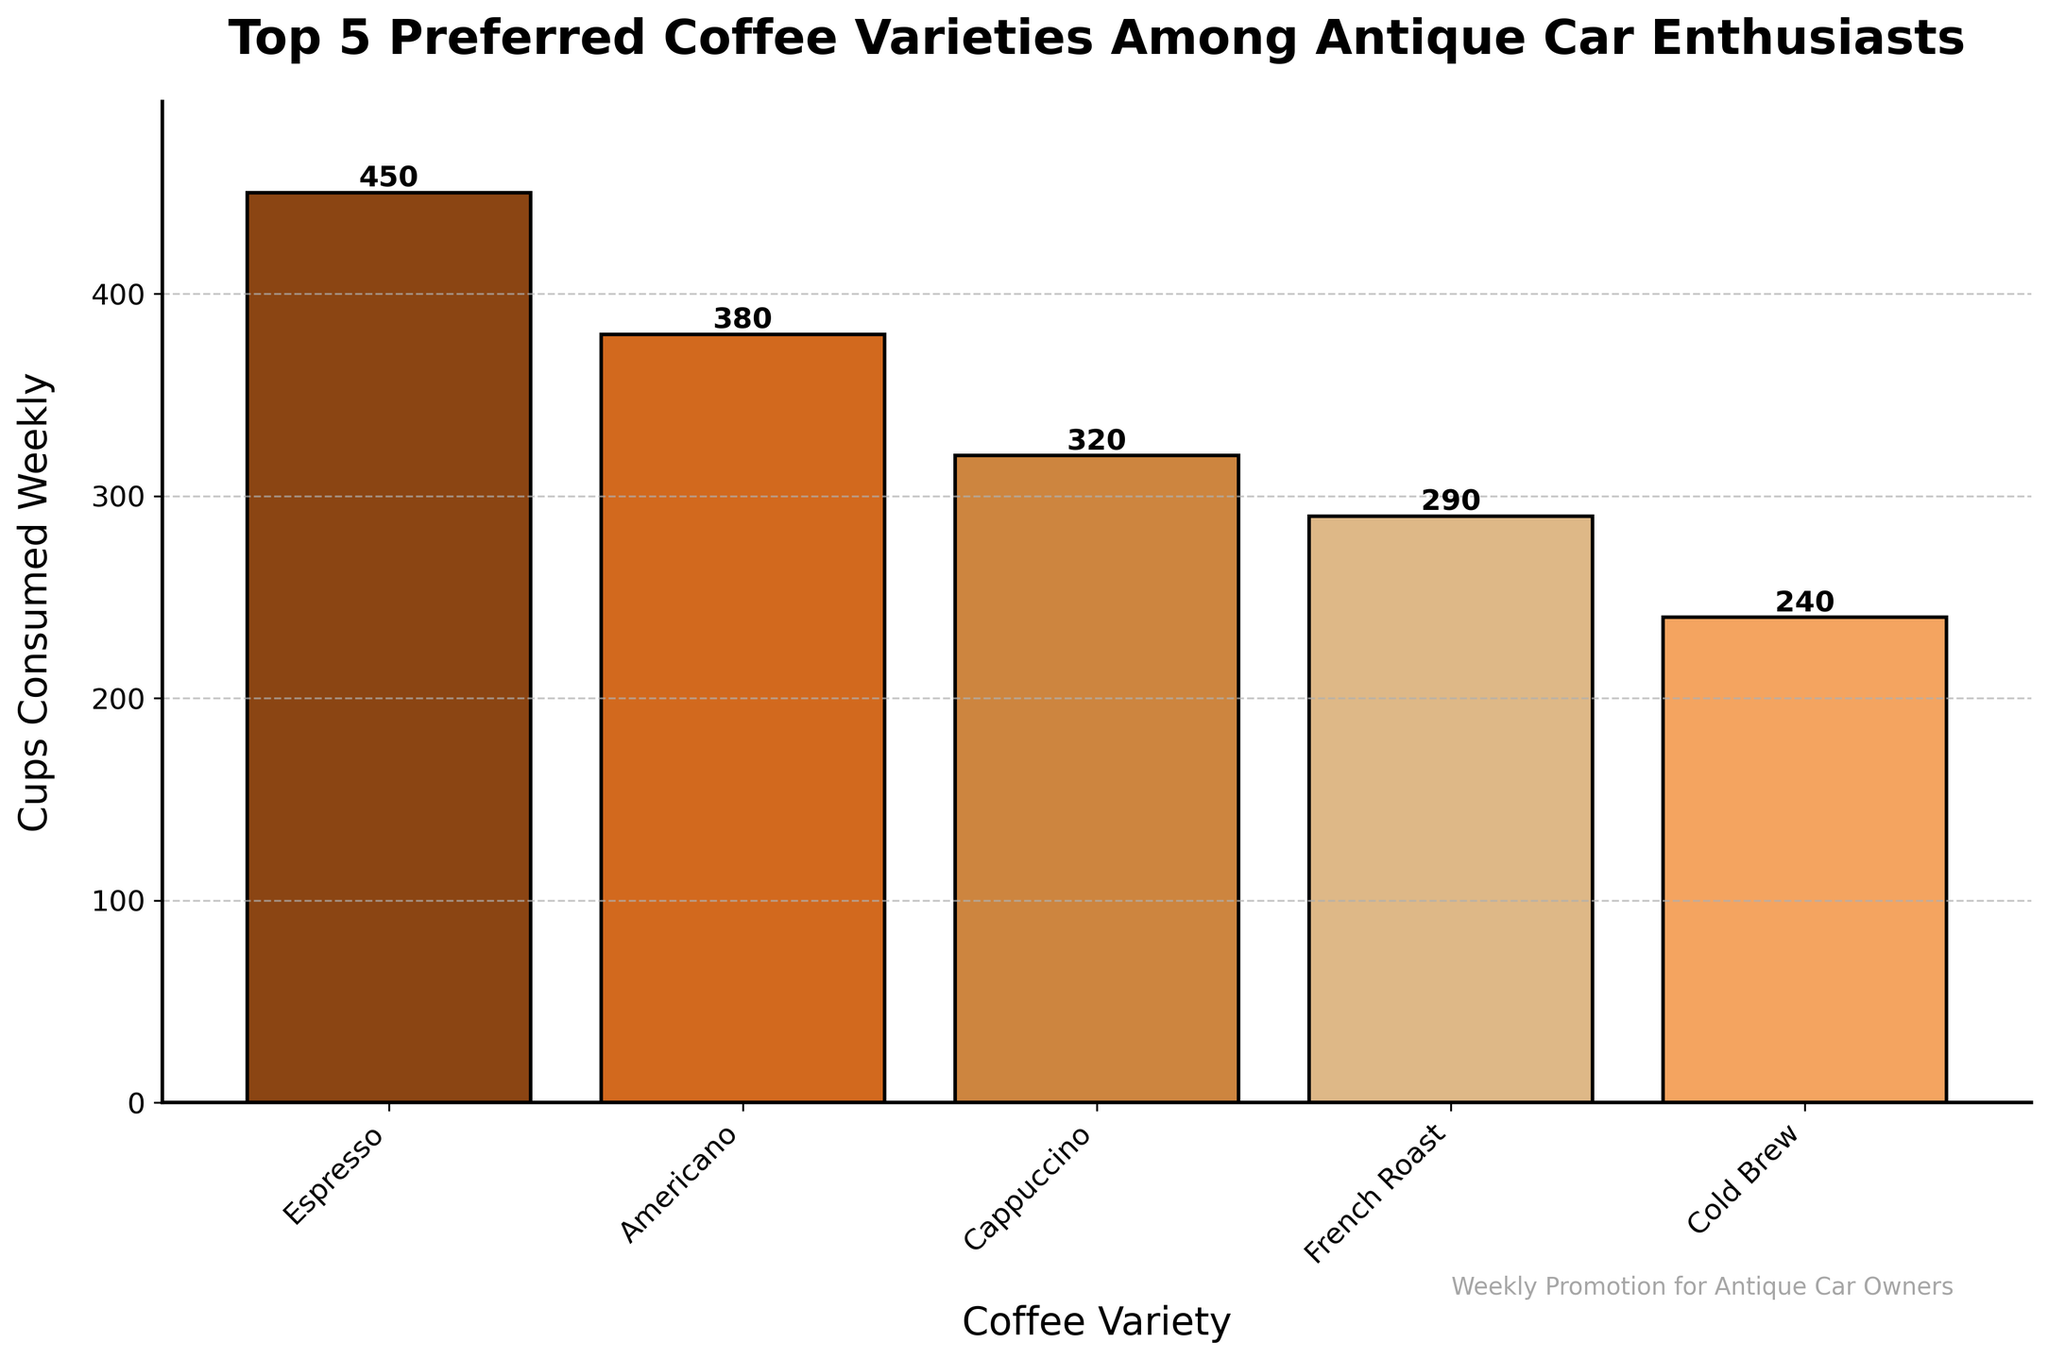What is the most popular coffee variety among antique car enthusiasts? The highest bar on the chart represents the most popular variety. The bar labeled "Espresso" has the highest height, indicating it is the most preferred.
Answer: Espresso Which coffee variety is consumed the least weekly by antique car enthusiasts? The shortest bar in the chart represents the least consumed variety. The bar labeled "Cold Brew" is the shortest, indicating it has the lowest weekly consumption.
Answer: Cold Brew How many more cups of Espresso are consumed weekly compared to Cold Brew? Subtract the number of cups consumed for Cold Brew from the number of cups consumed for Espresso: 450 (Espresso) - 240 (Cold Brew) = 210.
Answer: 210 What is the total weekly consumption of the top 3 coffee varieties (Espresso, Americano, and Cappuccino)? Add the weekly consumption of the top 3 varieties: 450 (Espresso) + 380 (Americano) + 320 (Cappuccino) = 1150.
Answer: 1150 Is the consumption of French Roast greater than that of Cold Brew? Compare the heights of the bars for French Roast and Cold Brew. The French Roast bar is taller than the Cold Brew bar, indicating greater consumption.
Answer: Yes What is the average weekly consumption of all five coffee varieties? Sum the total weekly consumption for all five varieties and divide by 5: (450 + 380 + 320 + 290 + 240) / 5 = 1680 / 5 = 336.
Answer: 336 By how many cups does the consumption of Americano exceed Cappuccino? Subtract the weekly consumption of Cappuccino from that of Americano: 380 (Americano) - 320 (Cappuccino) = 60.
Answer: 60 Which coffee variety is preferred more: French Roast or Americano? Compare the heights of the bars for French Roast and Americano. The Americano bar is taller than the French Roast bar.
Answer: Americano 